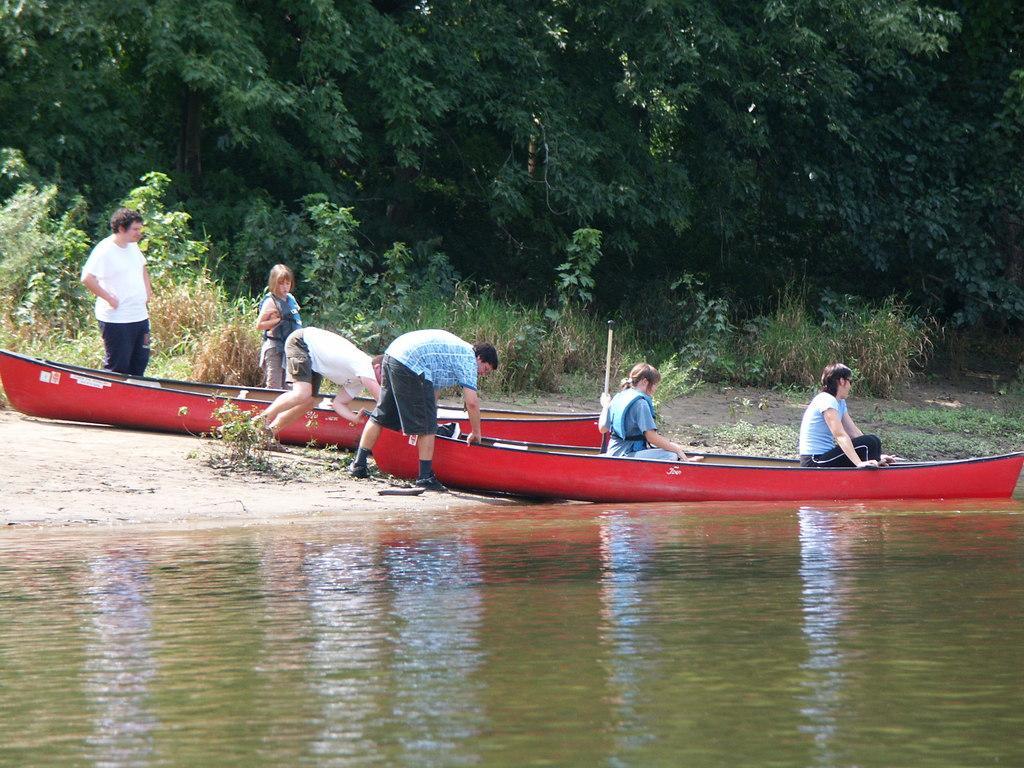In one or two sentences, can you explain what this image depicts? In this image, I can see few people standing and two people sitting in the boat. Here is the water. I can see two boats. These are the trees with branches and leaves. I can see the plants. 